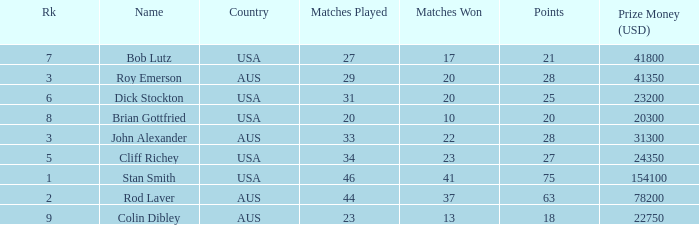How many matches did colin dibley win 13.0. 